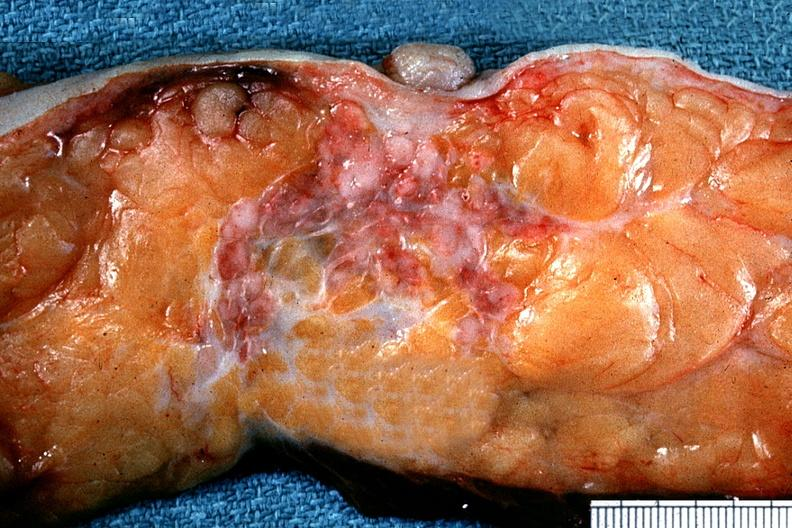what does this image show?
Answer the question using a single word or phrase. Excellent example of carcinoma below nipple in cross section 